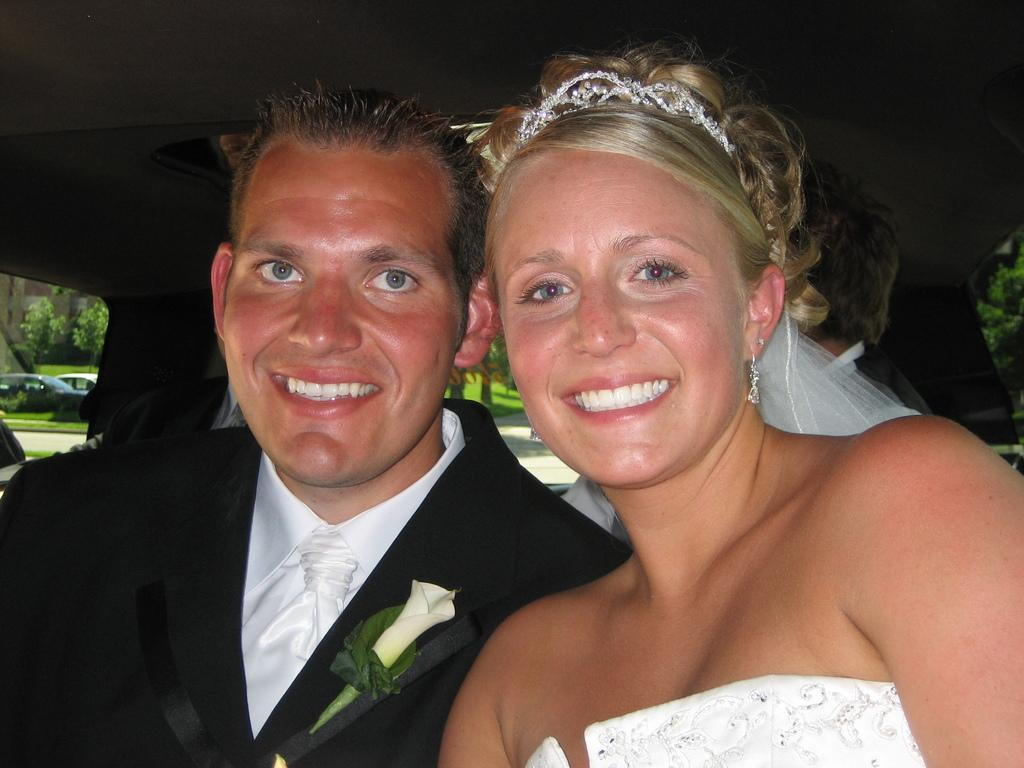How many people are in the image? There are two people in the image, a man and a woman. Where are the man and woman located in the image? The man and woman are in the center of the image. What type of cream is being applied to the notebook in the image? There is no notebook or cream present in the image. 